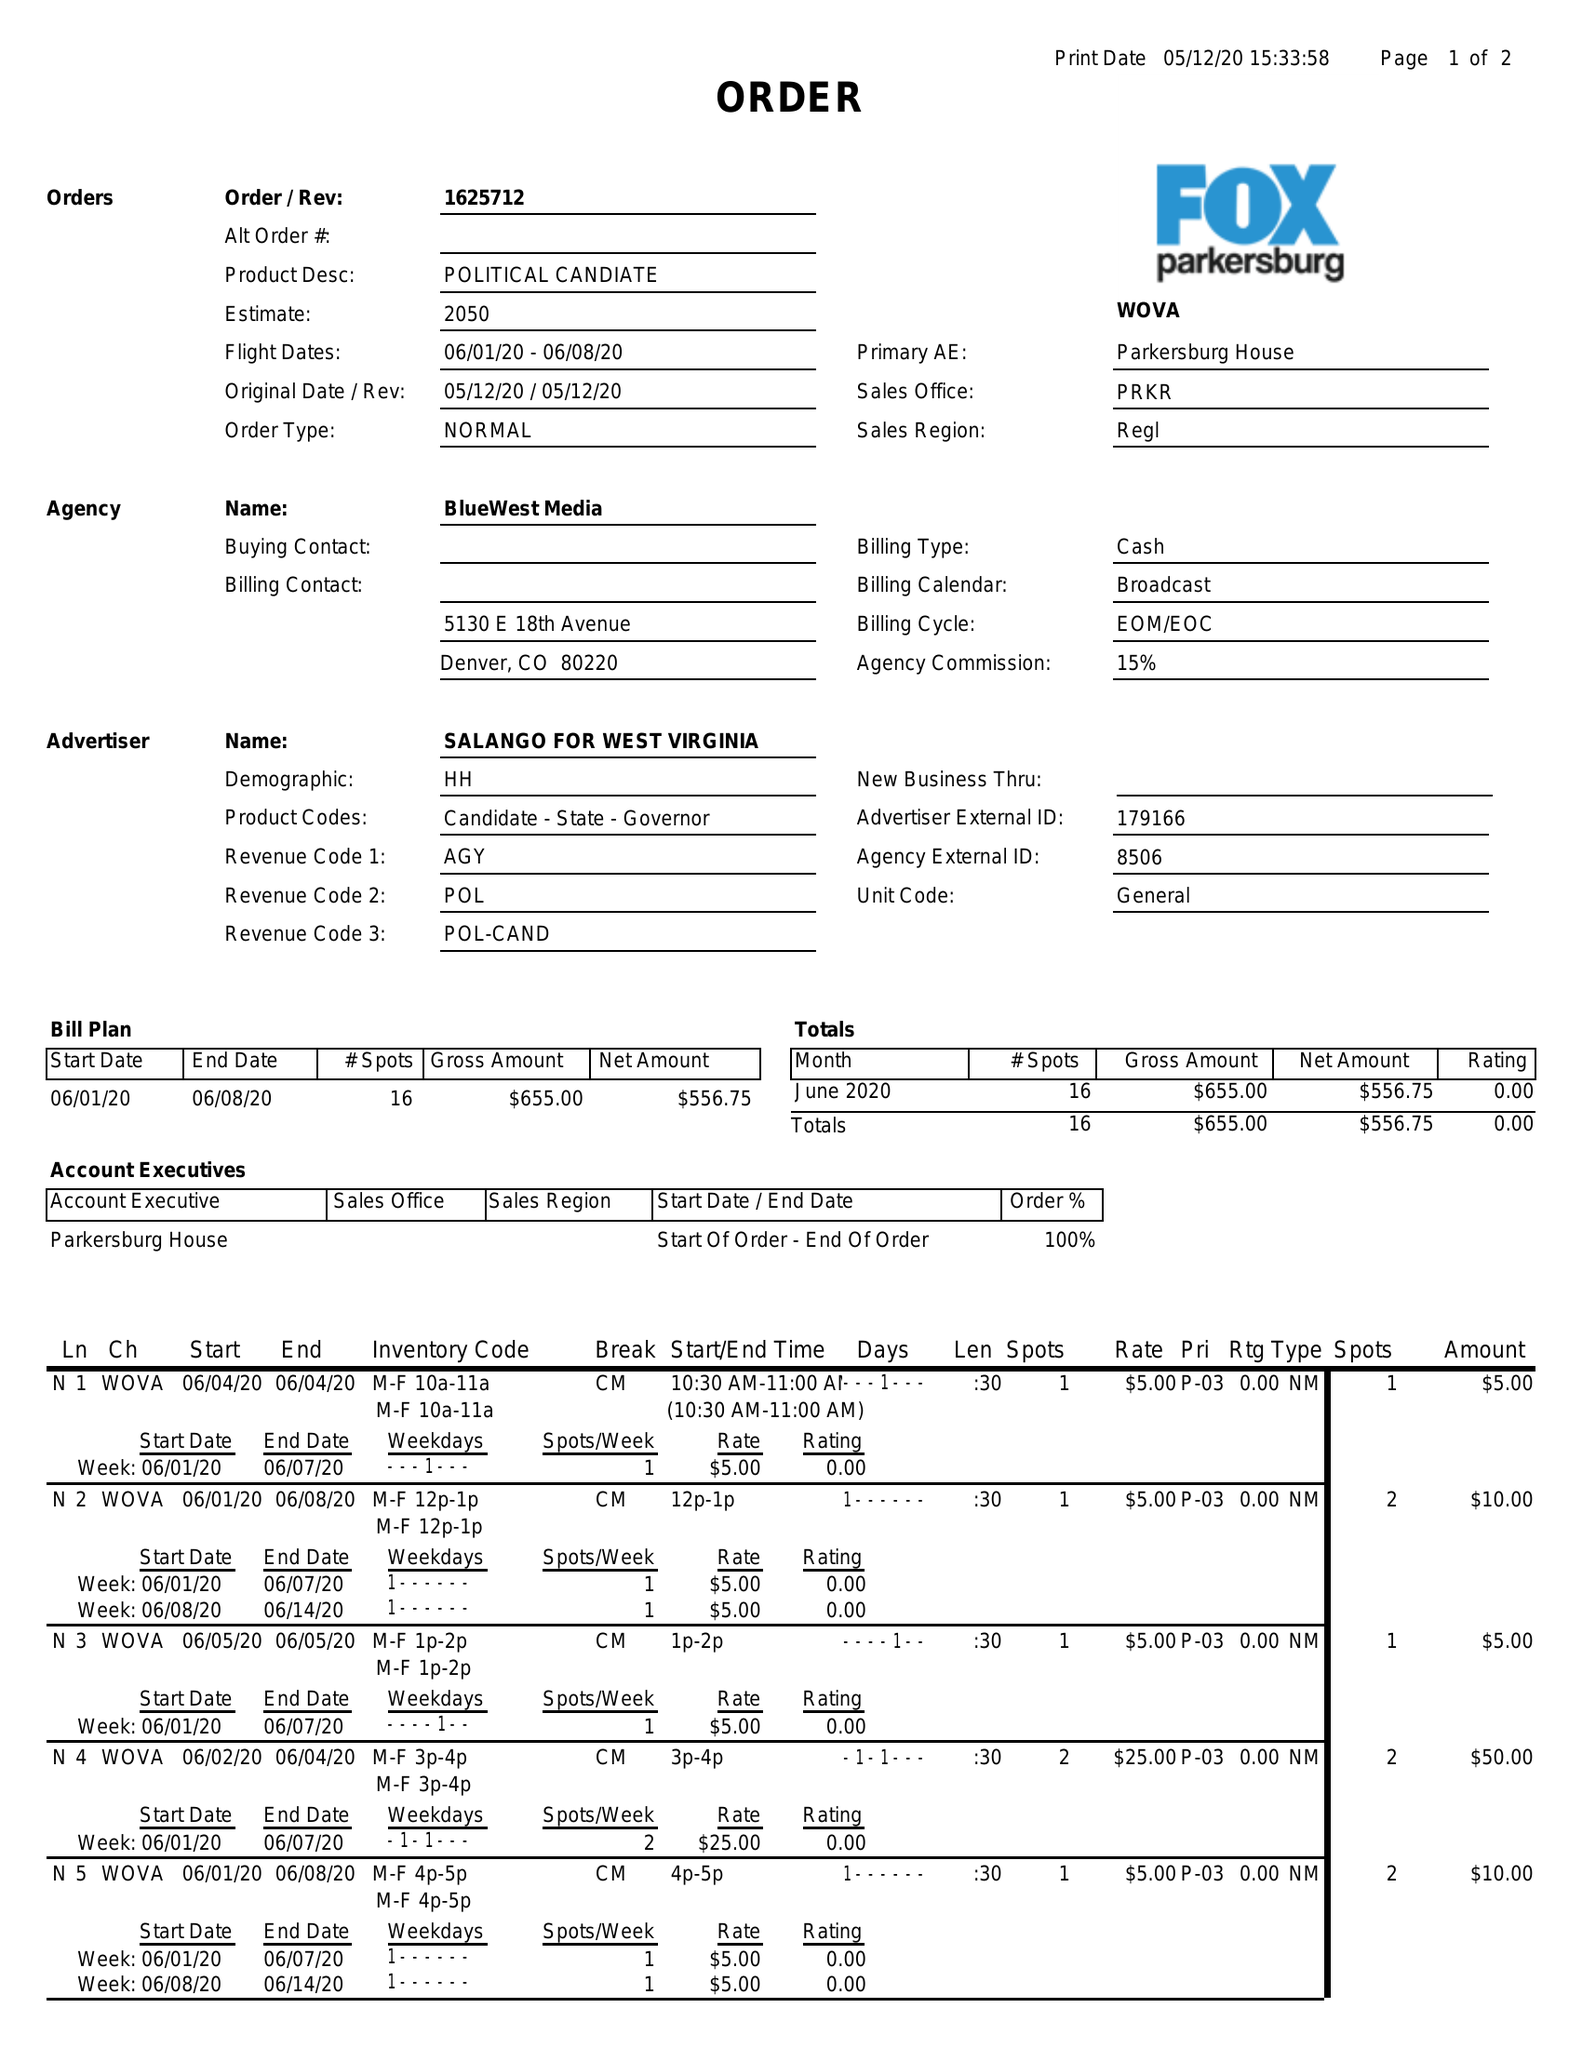What is the value for the gross_amount?
Answer the question using a single word or phrase. 655.00 